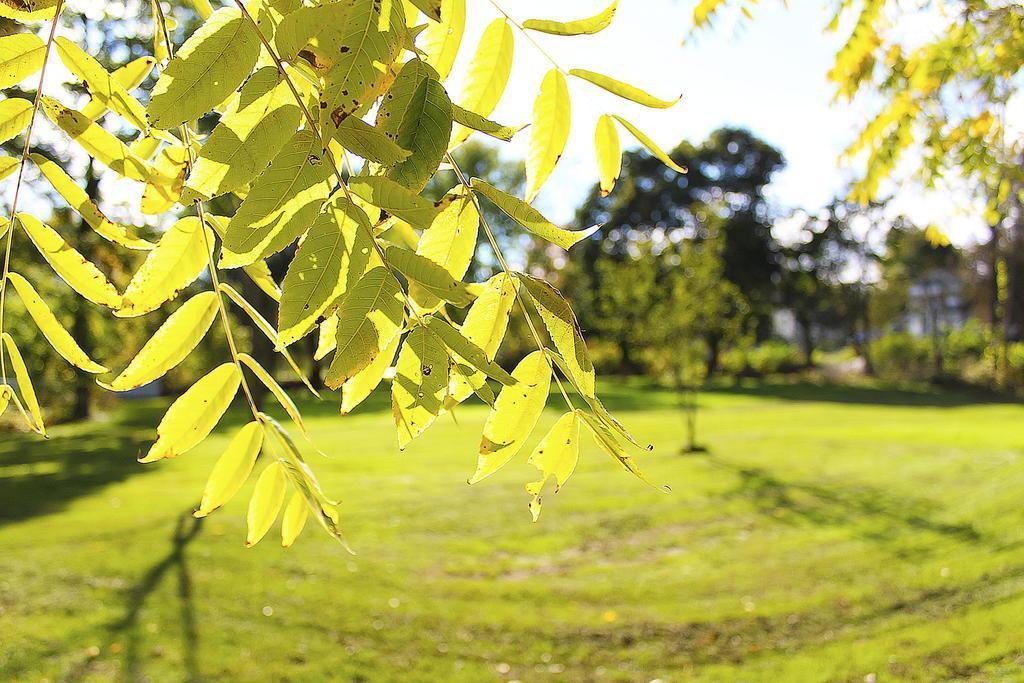Describe this image in one or two sentences. At the bottom of the image there is the surface of the grass. At the center of the image there are trees. At the top of the image we can see there are leaves of a tree. 